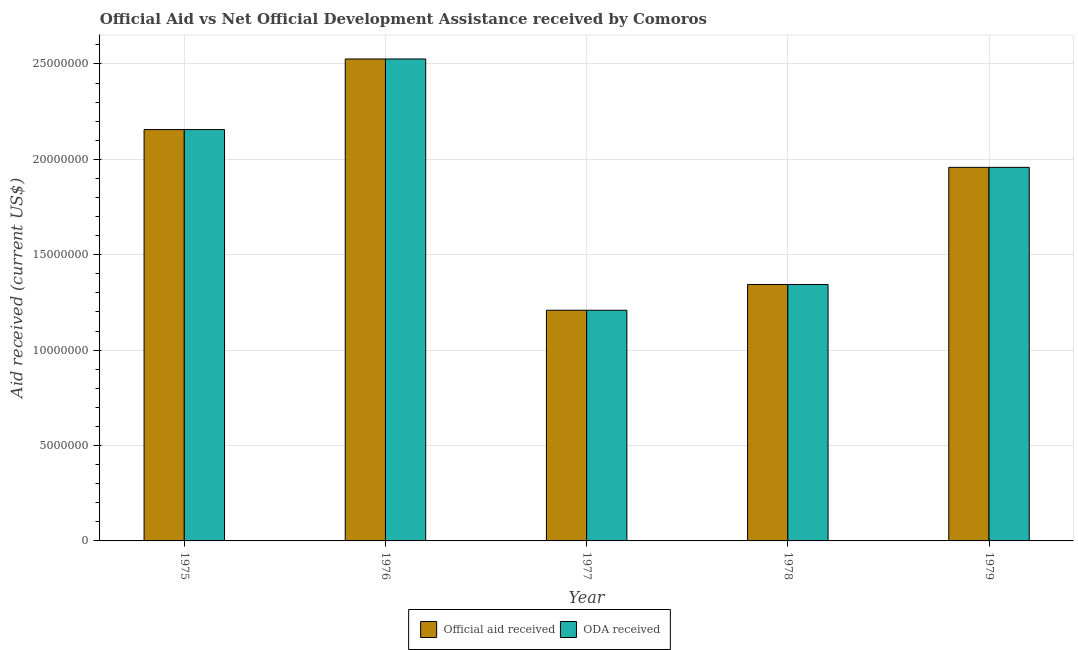What is the label of the 4th group of bars from the left?
Your answer should be compact. 1978. What is the oda received in 1979?
Make the answer very short. 1.96e+07. Across all years, what is the maximum official aid received?
Your answer should be compact. 2.53e+07. Across all years, what is the minimum official aid received?
Your answer should be compact. 1.21e+07. In which year was the official aid received maximum?
Offer a terse response. 1976. In which year was the oda received minimum?
Provide a succinct answer. 1977. What is the total official aid received in the graph?
Give a very brief answer. 9.19e+07. What is the difference between the oda received in 1977 and that in 1978?
Ensure brevity in your answer.  -1.35e+06. What is the difference between the oda received in 1976 and the official aid received in 1975?
Offer a very short reply. 3.70e+06. What is the average official aid received per year?
Offer a terse response. 1.84e+07. What is the ratio of the oda received in 1975 to that in 1978?
Provide a succinct answer. 1.6. Is the difference between the official aid received in 1977 and 1978 greater than the difference between the oda received in 1977 and 1978?
Your answer should be compact. No. What is the difference between the highest and the second highest oda received?
Ensure brevity in your answer.  3.70e+06. What is the difference between the highest and the lowest official aid received?
Provide a short and direct response. 1.32e+07. Is the sum of the official aid received in 1977 and 1978 greater than the maximum oda received across all years?
Give a very brief answer. Yes. What does the 2nd bar from the left in 1976 represents?
Offer a terse response. ODA received. What does the 1st bar from the right in 1977 represents?
Your response must be concise. ODA received. How many bars are there?
Offer a terse response. 10. Are all the bars in the graph horizontal?
Provide a succinct answer. No. How many years are there in the graph?
Your response must be concise. 5. What is the difference between two consecutive major ticks on the Y-axis?
Make the answer very short. 5.00e+06. Does the graph contain any zero values?
Make the answer very short. No. Where does the legend appear in the graph?
Offer a very short reply. Bottom center. What is the title of the graph?
Your response must be concise. Official Aid vs Net Official Development Assistance received by Comoros . Does "GDP" appear as one of the legend labels in the graph?
Your answer should be compact. No. What is the label or title of the X-axis?
Offer a terse response. Year. What is the label or title of the Y-axis?
Keep it short and to the point. Aid received (current US$). What is the Aid received (current US$) of Official aid received in 1975?
Ensure brevity in your answer.  2.16e+07. What is the Aid received (current US$) of ODA received in 1975?
Give a very brief answer. 2.16e+07. What is the Aid received (current US$) of Official aid received in 1976?
Give a very brief answer. 2.53e+07. What is the Aid received (current US$) of ODA received in 1976?
Your response must be concise. 2.53e+07. What is the Aid received (current US$) of Official aid received in 1977?
Your answer should be compact. 1.21e+07. What is the Aid received (current US$) of ODA received in 1977?
Offer a terse response. 1.21e+07. What is the Aid received (current US$) of Official aid received in 1978?
Make the answer very short. 1.34e+07. What is the Aid received (current US$) of ODA received in 1978?
Give a very brief answer. 1.34e+07. What is the Aid received (current US$) in Official aid received in 1979?
Your response must be concise. 1.96e+07. What is the Aid received (current US$) of ODA received in 1979?
Give a very brief answer. 1.96e+07. Across all years, what is the maximum Aid received (current US$) of Official aid received?
Provide a short and direct response. 2.53e+07. Across all years, what is the maximum Aid received (current US$) in ODA received?
Your response must be concise. 2.53e+07. Across all years, what is the minimum Aid received (current US$) in Official aid received?
Make the answer very short. 1.21e+07. Across all years, what is the minimum Aid received (current US$) of ODA received?
Your response must be concise. 1.21e+07. What is the total Aid received (current US$) in Official aid received in the graph?
Offer a very short reply. 9.19e+07. What is the total Aid received (current US$) of ODA received in the graph?
Offer a very short reply. 9.19e+07. What is the difference between the Aid received (current US$) in Official aid received in 1975 and that in 1976?
Your answer should be very brief. -3.70e+06. What is the difference between the Aid received (current US$) in ODA received in 1975 and that in 1976?
Offer a very short reply. -3.70e+06. What is the difference between the Aid received (current US$) in Official aid received in 1975 and that in 1977?
Keep it short and to the point. 9.47e+06. What is the difference between the Aid received (current US$) in ODA received in 1975 and that in 1977?
Provide a short and direct response. 9.47e+06. What is the difference between the Aid received (current US$) in Official aid received in 1975 and that in 1978?
Provide a succinct answer. 8.12e+06. What is the difference between the Aid received (current US$) in ODA received in 1975 and that in 1978?
Your answer should be very brief. 8.12e+06. What is the difference between the Aid received (current US$) of Official aid received in 1975 and that in 1979?
Offer a very short reply. 1.98e+06. What is the difference between the Aid received (current US$) of ODA received in 1975 and that in 1979?
Your answer should be very brief. 1.98e+06. What is the difference between the Aid received (current US$) of Official aid received in 1976 and that in 1977?
Keep it short and to the point. 1.32e+07. What is the difference between the Aid received (current US$) of ODA received in 1976 and that in 1977?
Your answer should be compact. 1.32e+07. What is the difference between the Aid received (current US$) in Official aid received in 1976 and that in 1978?
Offer a very short reply. 1.18e+07. What is the difference between the Aid received (current US$) in ODA received in 1976 and that in 1978?
Ensure brevity in your answer.  1.18e+07. What is the difference between the Aid received (current US$) in Official aid received in 1976 and that in 1979?
Offer a very short reply. 5.68e+06. What is the difference between the Aid received (current US$) in ODA received in 1976 and that in 1979?
Ensure brevity in your answer.  5.68e+06. What is the difference between the Aid received (current US$) in Official aid received in 1977 and that in 1978?
Offer a terse response. -1.35e+06. What is the difference between the Aid received (current US$) of ODA received in 1977 and that in 1978?
Offer a very short reply. -1.35e+06. What is the difference between the Aid received (current US$) in Official aid received in 1977 and that in 1979?
Your answer should be very brief. -7.49e+06. What is the difference between the Aid received (current US$) of ODA received in 1977 and that in 1979?
Your answer should be compact. -7.49e+06. What is the difference between the Aid received (current US$) of Official aid received in 1978 and that in 1979?
Make the answer very short. -6.14e+06. What is the difference between the Aid received (current US$) of ODA received in 1978 and that in 1979?
Make the answer very short. -6.14e+06. What is the difference between the Aid received (current US$) in Official aid received in 1975 and the Aid received (current US$) in ODA received in 1976?
Provide a succinct answer. -3.70e+06. What is the difference between the Aid received (current US$) of Official aid received in 1975 and the Aid received (current US$) of ODA received in 1977?
Provide a short and direct response. 9.47e+06. What is the difference between the Aid received (current US$) of Official aid received in 1975 and the Aid received (current US$) of ODA received in 1978?
Offer a very short reply. 8.12e+06. What is the difference between the Aid received (current US$) of Official aid received in 1975 and the Aid received (current US$) of ODA received in 1979?
Your answer should be very brief. 1.98e+06. What is the difference between the Aid received (current US$) in Official aid received in 1976 and the Aid received (current US$) in ODA received in 1977?
Your answer should be compact. 1.32e+07. What is the difference between the Aid received (current US$) in Official aid received in 1976 and the Aid received (current US$) in ODA received in 1978?
Ensure brevity in your answer.  1.18e+07. What is the difference between the Aid received (current US$) of Official aid received in 1976 and the Aid received (current US$) of ODA received in 1979?
Your answer should be compact. 5.68e+06. What is the difference between the Aid received (current US$) of Official aid received in 1977 and the Aid received (current US$) of ODA received in 1978?
Offer a very short reply. -1.35e+06. What is the difference between the Aid received (current US$) of Official aid received in 1977 and the Aid received (current US$) of ODA received in 1979?
Offer a very short reply. -7.49e+06. What is the difference between the Aid received (current US$) in Official aid received in 1978 and the Aid received (current US$) in ODA received in 1979?
Your answer should be compact. -6.14e+06. What is the average Aid received (current US$) of Official aid received per year?
Provide a succinct answer. 1.84e+07. What is the average Aid received (current US$) of ODA received per year?
Provide a succinct answer. 1.84e+07. In the year 1975, what is the difference between the Aid received (current US$) in Official aid received and Aid received (current US$) in ODA received?
Your answer should be compact. 0. In the year 1978, what is the difference between the Aid received (current US$) in Official aid received and Aid received (current US$) in ODA received?
Your response must be concise. 0. In the year 1979, what is the difference between the Aid received (current US$) in Official aid received and Aid received (current US$) in ODA received?
Your answer should be very brief. 0. What is the ratio of the Aid received (current US$) of Official aid received in 1975 to that in 1976?
Your response must be concise. 0.85. What is the ratio of the Aid received (current US$) in ODA received in 1975 to that in 1976?
Keep it short and to the point. 0.85. What is the ratio of the Aid received (current US$) in Official aid received in 1975 to that in 1977?
Your response must be concise. 1.78. What is the ratio of the Aid received (current US$) in ODA received in 1975 to that in 1977?
Your response must be concise. 1.78. What is the ratio of the Aid received (current US$) of Official aid received in 1975 to that in 1978?
Give a very brief answer. 1.6. What is the ratio of the Aid received (current US$) in ODA received in 1975 to that in 1978?
Ensure brevity in your answer.  1.6. What is the ratio of the Aid received (current US$) in Official aid received in 1975 to that in 1979?
Give a very brief answer. 1.1. What is the ratio of the Aid received (current US$) of ODA received in 1975 to that in 1979?
Offer a terse response. 1.1. What is the ratio of the Aid received (current US$) in Official aid received in 1976 to that in 1977?
Provide a short and direct response. 2.09. What is the ratio of the Aid received (current US$) in ODA received in 1976 to that in 1977?
Make the answer very short. 2.09. What is the ratio of the Aid received (current US$) of Official aid received in 1976 to that in 1978?
Your answer should be compact. 1.88. What is the ratio of the Aid received (current US$) in ODA received in 1976 to that in 1978?
Offer a very short reply. 1.88. What is the ratio of the Aid received (current US$) of Official aid received in 1976 to that in 1979?
Make the answer very short. 1.29. What is the ratio of the Aid received (current US$) in ODA received in 1976 to that in 1979?
Provide a succinct answer. 1.29. What is the ratio of the Aid received (current US$) in Official aid received in 1977 to that in 1978?
Your response must be concise. 0.9. What is the ratio of the Aid received (current US$) in ODA received in 1977 to that in 1978?
Give a very brief answer. 0.9. What is the ratio of the Aid received (current US$) in Official aid received in 1977 to that in 1979?
Your answer should be very brief. 0.62. What is the ratio of the Aid received (current US$) in ODA received in 1977 to that in 1979?
Offer a terse response. 0.62. What is the ratio of the Aid received (current US$) of Official aid received in 1978 to that in 1979?
Your response must be concise. 0.69. What is the ratio of the Aid received (current US$) of ODA received in 1978 to that in 1979?
Your answer should be compact. 0.69. What is the difference between the highest and the second highest Aid received (current US$) in Official aid received?
Provide a short and direct response. 3.70e+06. What is the difference between the highest and the second highest Aid received (current US$) in ODA received?
Provide a succinct answer. 3.70e+06. What is the difference between the highest and the lowest Aid received (current US$) of Official aid received?
Keep it short and to the point. 1.32e+07. What is the difference between the highest and the lowest Aid received (current US$) of ODA received?
Ensure brevity in your answer.  1.32e+07. 